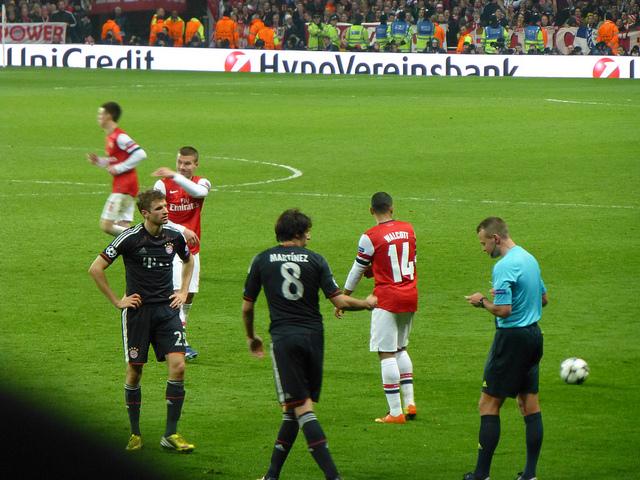What sport is being played?
Give a very brief answer. Soccer. Will grass stains be hard to get out of these uniforms?
Keep it brief. Yes. What color are the uniforms?
Concise answer only. Black, red and white. Is this a professional game?
Concise answer only. Yes. What position does the player on the left play?
Concise answer only. Center. What game are they playing?
Concise answer only. Soccer. What color is the ball?
Give a very brief answer. White. What teams are playing?
Answer briefly. Black and red. Is the soccer ball lying on a field stripe?
Write a very short answer. No. 